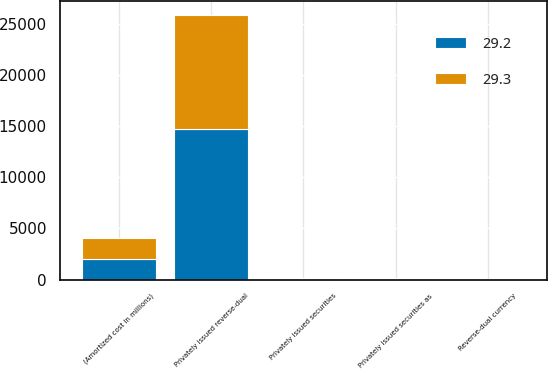Convert chart. <chart><loc_0><loc_0><loc_500><loc_500><stacked_bar_chart><ecel><fcel>(Amortized cost in millions)<fcel>Privately issued securities as<fcel>Privately issued securities<fcel>Privately issued reverse-dual<fcel>Reverse-dual currency<nl><fcel>29.2<fcel>2008<fcel>72<fcel>68.3<fcel>14678<fcel>29.3<nl><fcel>29.3<fcel>2007<fcel>70.3<fcel>66<fcel>11185<fcel>29.2<nl></chart> 